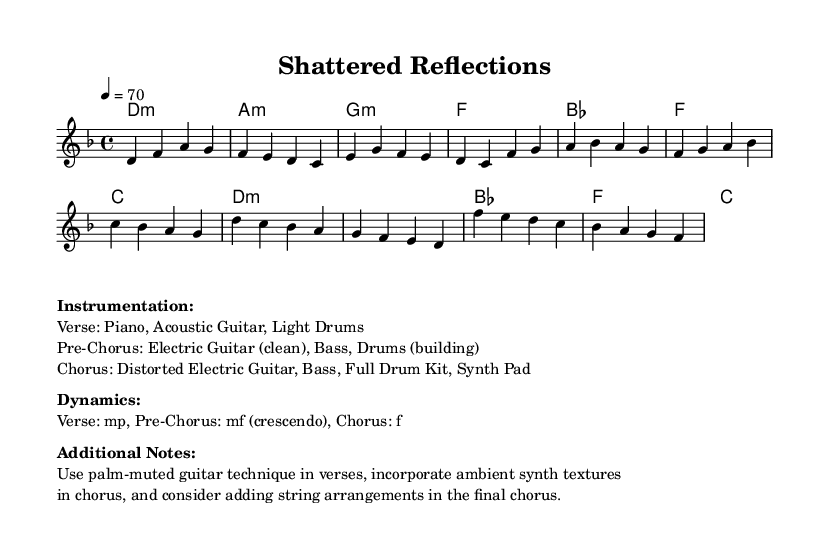What is the key signature of this music? The key signature is D minor, indicated by one flat (B flat) in the key signature section of the sheet music.
Answer: D minor What is the time signature of this piece? The time signature is 4/4, which means there are four beats in each measure and the quarter note gets one beat. This is easily recognizable from the notation at the beginning of the score.
Answer: 4/4 What is the tempo marking of the piece? The tempo marking is 70 beats per minute, indicated by the tempo indication "4 = 70" at the beginning of the score. This shows the speed at which the music should be played.
Answer: 70 What instrumentation is used in the Verse section? The instrumentation indicated for the Verse is Piano, Acoustic Guitar, and Light Drums. This is mentioned under the "Instrumentation" section following the score.
Answer: Piano, Acoustic Guitar, Light Drums How does the dynamics change from the Verse to the Chorus? The dynamics change from mp (mezzo-piano, moderately soft) in the Verse to f (forte, loud) in the Chorus, indicating an increase in volume and intensity as the piece progresses. This shows a contrast in dynamics that is common in pop ballads.
Answer: mp to f How does the Pre-Chorus build up the tension before the Chorus? In the Pre-Chorus, the dynamics are marked as mf (mezzo-forte, moderately loud) with a crescendo, suggesting that the music gradually gets louder leading up to the Chorus. This dynamic buildup is a common technique used to enhance the emotional impact before the main statement of the song.
Answer: mf (crescendo) What specific technique is suggested for the guitar in the Verse? The suggested technique for the guitar in the Verse is palm-muted, which creates a muted, percussive sound, adding texture to the softer sections of the piece. This is noted under the "Additional Notes" section.
Answer: Palm-muted 